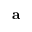<formula> <loc_0><loc_0><loc_500><loc_500>a</formula> 